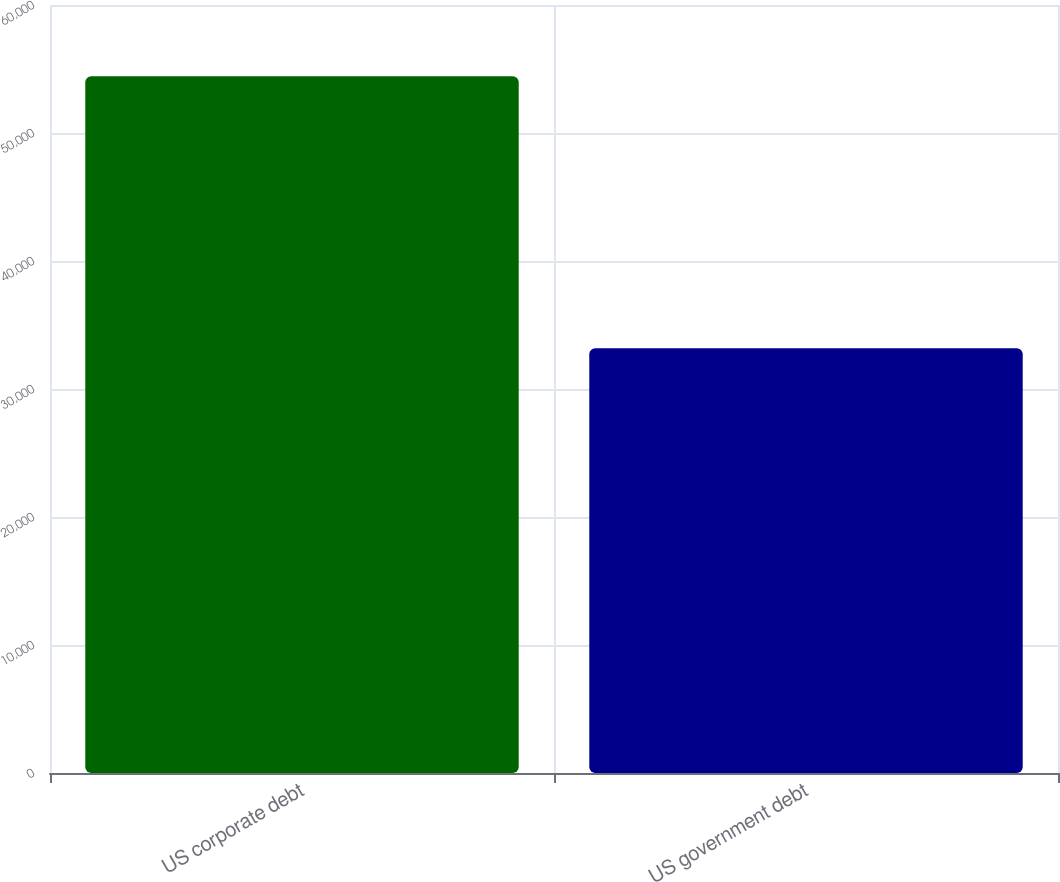<chart> <loc_0><loc_0><loc_500><loc_500><bar_chart><fcel>US corporate debt<fcel>US government debt<nl><fcel>54430<fcel>33188<nl></chart> 